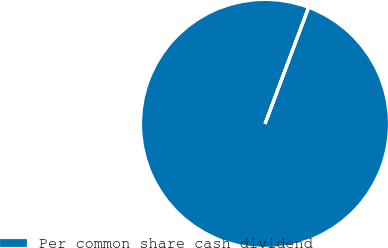<chart> <loc_0><loc_0><loc_500><loc_500><pie_chart><fcel>Per common share cash dividend<nl><fcel>100.0%<nl></chart> 